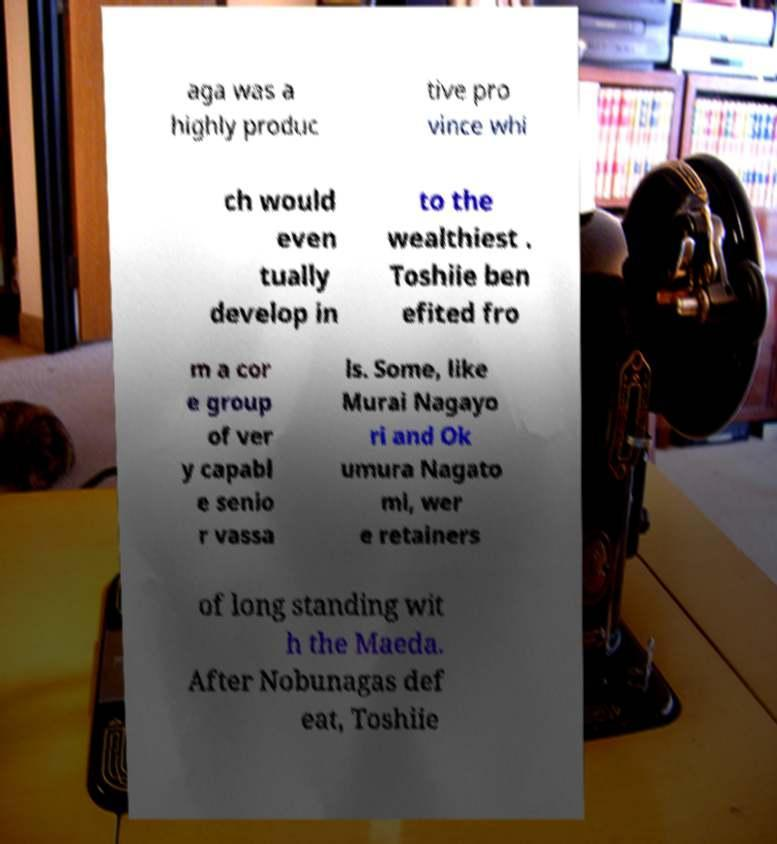What messages or text are displayed in this image? I need them in a readable, typed format. aga was a highly produc tive pro vince whi ch would even tually develop in to the wealthiest . Toshiie ben efited fro m a cor e group of ver y capabl e senio r vassa ls. Some, like Murai Nagayo ri and Ok umura Nagato mi, wer e retainers of long standing wit h the Maeda. After Nobunagas def eat, Toshiie 